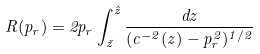Convert formula to latex. <formula><loc_0><loc_0><loc_500><loc_500>R ( p _ { r } ) = 2 p _ { r } \int _ { \check { z } } ^ { \hat { z } } \frac { d z } { ( c ^ { - 2 } ( z ) - p _ { r } ^ { 2 } ) ^ { 1 / 2 } }</formula> 